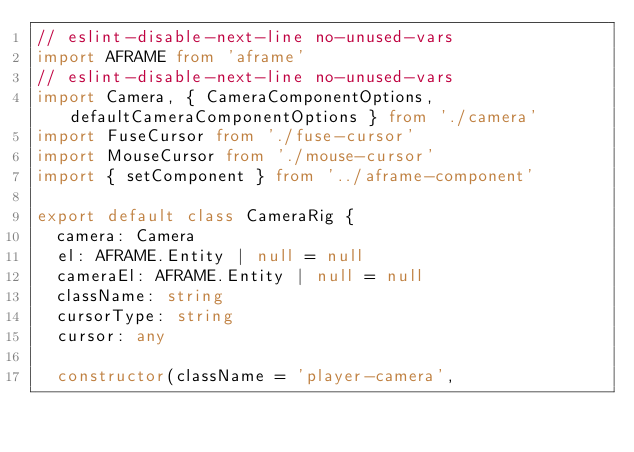Convert code to text. <code><loc_0><loc_0><loc_500><loc_500><_TypeScript_>// eslint-disable-next-line no-unused-vars
import AFRAME from 'aframe'
// eslint-disable-next-line no-unused-vars
import Camera, { CameraComponentOptions, defaultCameraComponentOptions } from './camera'
import FuseCursor from './fuse-cursor'
import MouseCursor from './mouse-cursor'
import { setComponent } from '../aframe-component'

export default class CameraRig {
  camera: Camera
  el: AFRAME.Entity | null = null
  cameraEl: AFRAME.Entity | null = null
  className: string
  cursorType: string
  cursor: any

  constructor(className = 'player-camera',</code> 